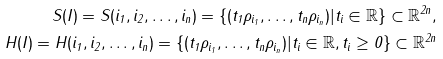<formula> <loc_0><loc_0><loc_500><loc_500>S ( I ) = S ( i _ { 1 } , i _ { 2 } , \dots , i _ { n } ) = \{ ( t _ { 1 } \rho _ { i _ { 1 } } , \dots , t _ { n } \rho _ { i _ { n } } ) | t _ { i } \in \mathbb { R } \} \subset \mathbb { R } ^ { 2 n } , \\ H ( I ) = H ( i _ { 1 } , i _ { 2 } , \dots , i _ { n } ) = \{ ( t _ { 1 } \rho _ { i _ { 1 } } , \dots , t _ { n } \rho _ { i _ { n } } ) | t _ { i } \in \mathbb { R } , t _ { i } \geq 0 \} \subset \mathbb { R } ^ { 2 n }</formula> 